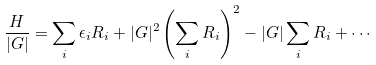Convert formula to latex. <formula><loc_0><loc_0><loc_500><loc_500>\frac { H } { | G | } = \sum _ { i } \epsilon _ { i } R _ { i } + | G | ^ { 2 } \left ( \sum _ { i } R _ { i } \right ) ^ { 2 } - | G | \sum _ { i } R _ { i } + \cdots</formula> 